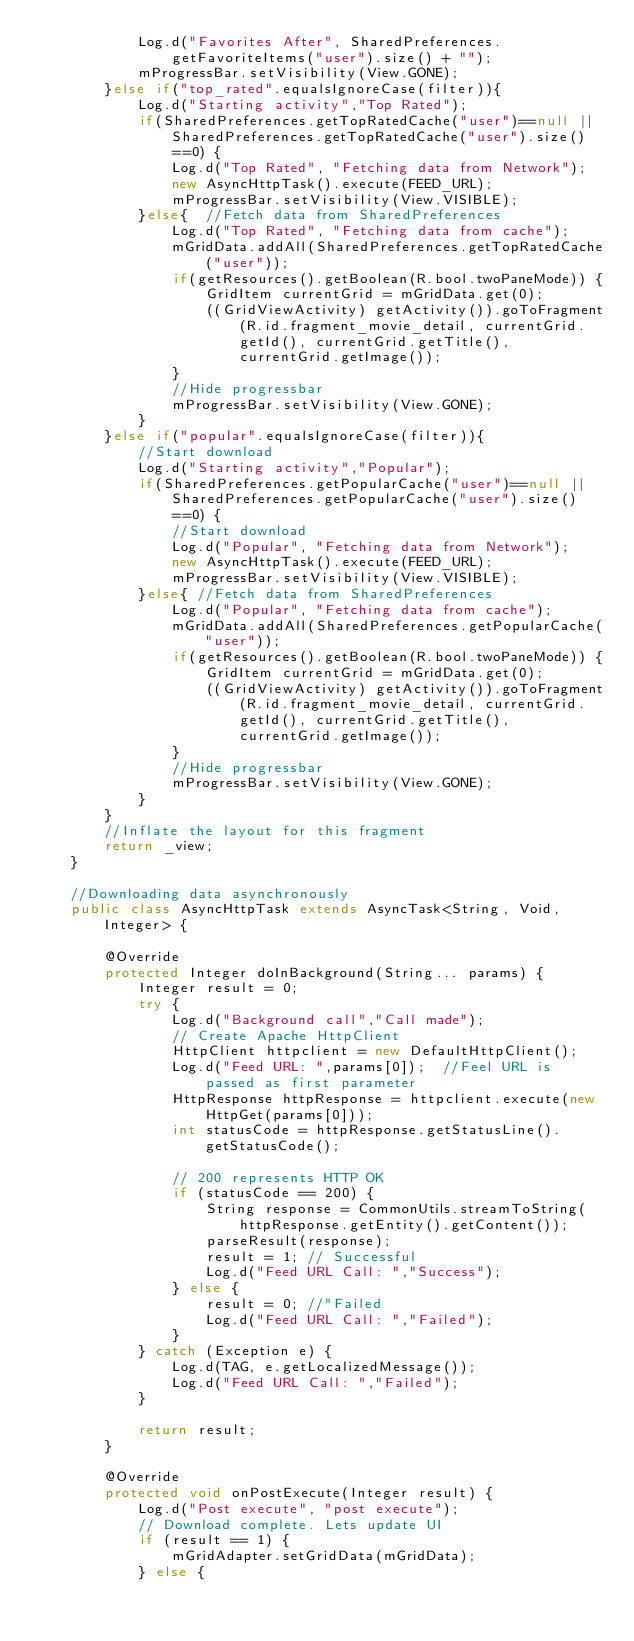<code> <loc_0><loc_0><loc_500><loc_500><_Java_>            Log.d("Favorites After", SharedPreferences.getFavoriteItems("user").size() + "");
            mProgressBar.setVisibility(View.GONE);
        }else if("top_rated".equalsIgnoreCase(filter)){
            Log.d("Starting activity","Top Rated");
            if(SharedPreferences.getTopRatedCache("user")==null || SharedPreferences.getTopRatedCache("user").size()==0) {
                Log.d("Top Rated", "Fetching data from Network");
                new AsyncHttpTask().execute(FEED_URL);
                mProgressBar.setVisibility(View.VISIBLE);
            }else{  //Fetch data from SharedPreferences
                Log.d("Top Rated", "Fetching data from cache");
                mGridData.addAll(SharedPreferences.getTopRatedCache("user"));
                if(getResources().getBoolean(R.bool.twoPaneMode)) {
                    GridItem currentGrid = mGridData.get(0);
                    ((GridViewActivity) getActivity()).goToFragment(R.id.fragment_movie_detail, currentGrid.getId(), currentGrid.getTitle(), currentGrid.getImage());
                }
                //Hide progressbar
                mProgressBar.setVisibility(View.GONE);
            }
        }else if("popular".equalsIgnoreCase(filter)){
            //Start download
            Log.d("Starting activity","Popular");
            if(SharedPreferences.getPopularCache("user")==null || SharedPreferences.getPopularCache("user").size()==0) {
                //Start download
                Log.d("Popular", "Fetching data from Network");
                new AsyncHttpTask().execute(FEED_URL);
                mProgressBar.setVisibility(View.VISIBLE);
            }else{ //Fetch data from SharedPreferences
                Log.d("Popular", "Fetching data from cache");
                mGridData.addAll(SharedPreferences.getPopularCache("user"));
                if(getResources().getBoolean(R.bool.twoPaneMode)) {
                    GridItem currentGrid = mGridData.get(0);
                    ((GridViewActivity) getActivity()).goToFragment(R.id.fragment_movie_detail, currentGrid.getId(), currentGrid.getTitle(), currentGrid.getImage());
                }
                //Hide progressbar
                mProgressBar.setVisibility(View.GONE);
            }
        }
        //Inflate the layout for this fragment
        return _view;
    }

    //Downloading data asynchronously
    public class AsyncHttpTask extends AsyncTask<String, Void, Integer> {

        @Override
        protected Integer doInBackground(String... params) {
            Integer result = 0;
            try {
                Log.d("Background call","Call made");
                // Create Apache HttpClient
                HttpClient httpclient = new DefaultHttpClient();
                Log.d("Feed URL: ",params[0]);  //Feel URL is passed as first parameter
                HttpResponse httpResponse = httpclient.execute(new HttpGet(params[0]));
                int statusCode = httpResponse.getStatusLine().getStatusCode();

                // 200 represents HTTP OK
                if (statusCode == 200) {
                    String response = CommonUtils.streamToString(httpResponse.getEntity().getContent());
                    parseResult(response);
                    result = 1; // Successful
                    Log.d("Feed URL Call: ","Success");
                } else {
                    result = 0; //"Failed
                    Log.d("Feed URL Call: ","Failed");
                }
            } catch (Exception e) {
                Log.d(TAG, e.getLocalizedMessage());
                Log.d("Feed URL Call: ","Failed");
            }

            return result;
        }

        @Override
        protected void onPostExecute(Integer result) {
            Log.d("Post execute", "post execute");
            // Download complete. Lets update UI
            if (result == 1) {
                mGridAdapter.setGridData(mGridData);
            } else {</code> 